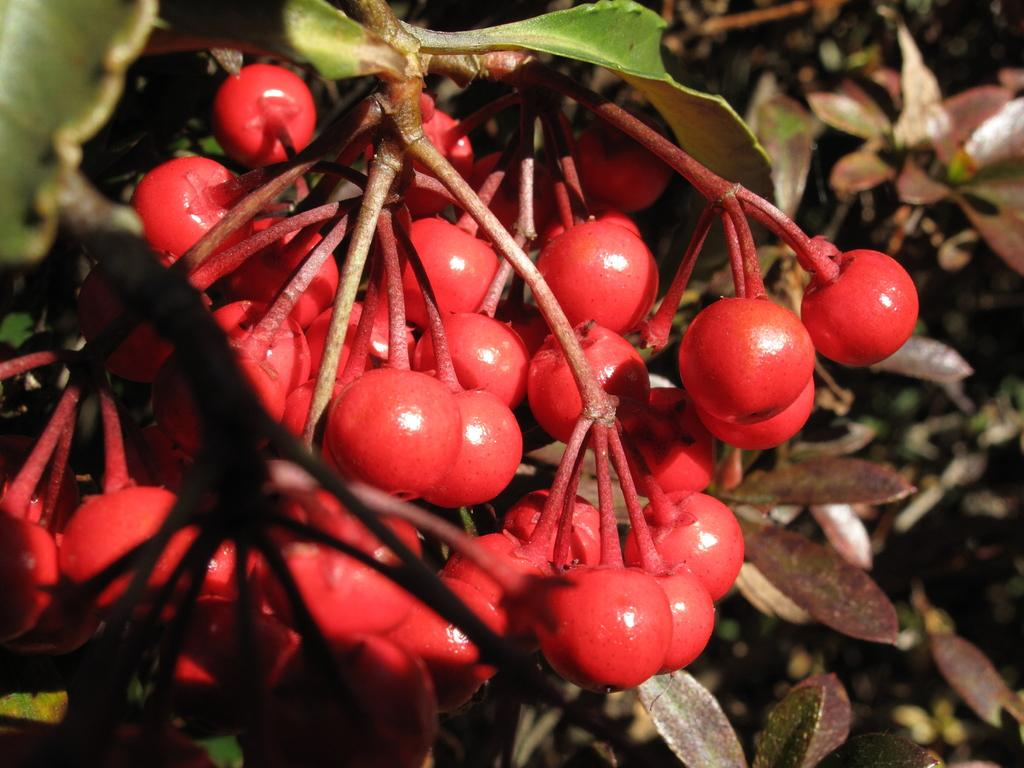What is present in the image? There is a tree in the image. What is special about the tree? The tree has a bunch of cherries on it. What color is the silverware on the tree? There is no silverware present on the tree; it has a bunch of cherries instead. 